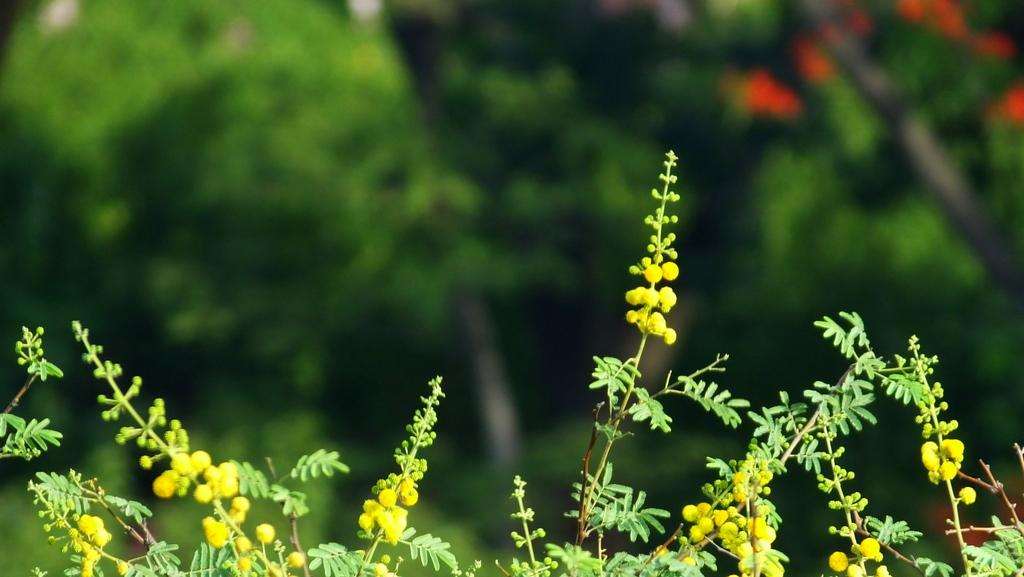What type of living organisms can be seen in the image? Plants can be seen in the image. Can you describe the background of the image? The background of the image is blurred. What type of hand can be seen holding the bushes in the image? There is no hand or bushes present in the image; it only features plants. What type of crook is visible in the image? There is no crook present in the image. 